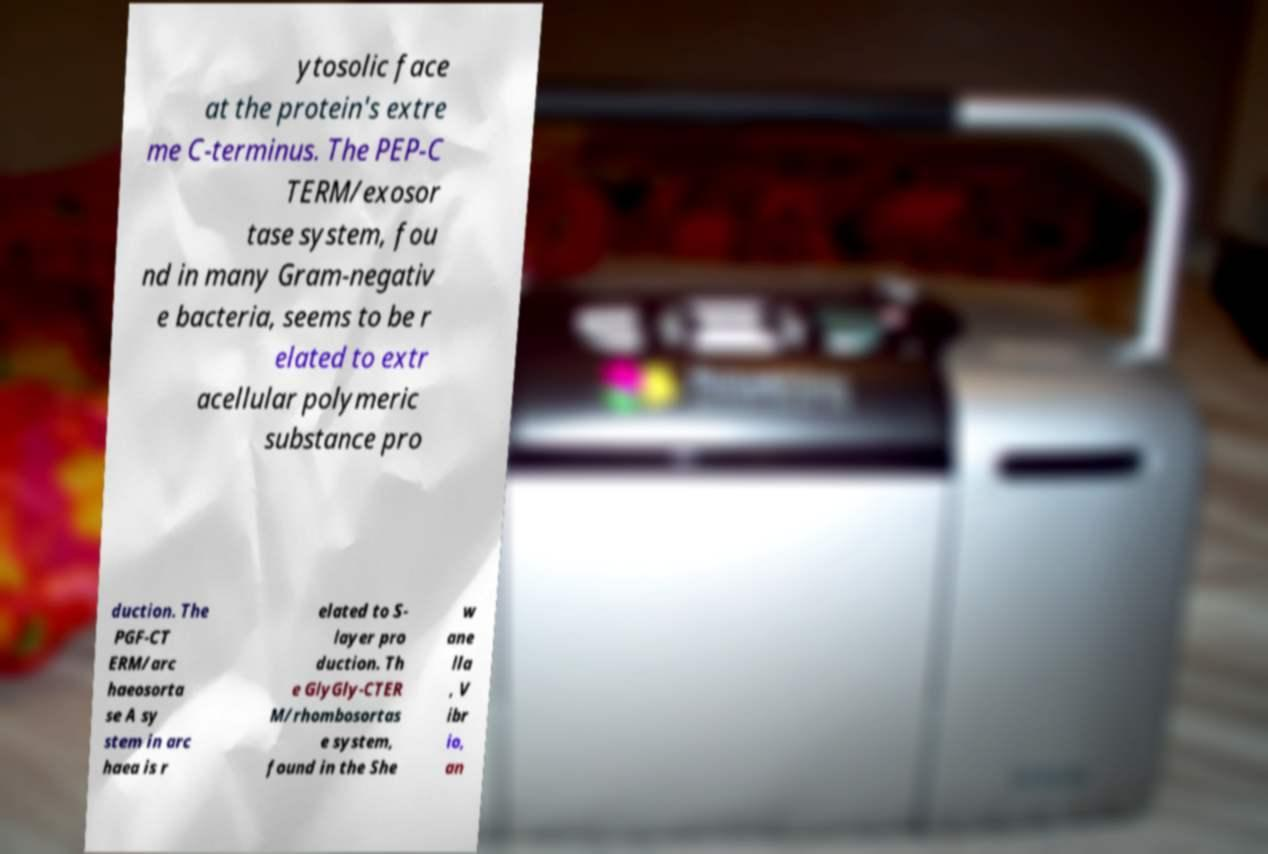Can you accurately transcribe the text from the provided image for me? ytosolic face at the protein's extre me C-terminus. The PEP-C TERM/exosor tase system, fou nd in many Gram-negativ e bacteria, seems to be r elated to extr acellular polymeric substance pro duction. The PGF-CT ERM/arc haeosorta se A sy stem in arc haea is r elated to S- layer pro duction. Th e GlyGly-CTER M/rhombosortas e system, found in the She w ane lla , V ibr io, an 